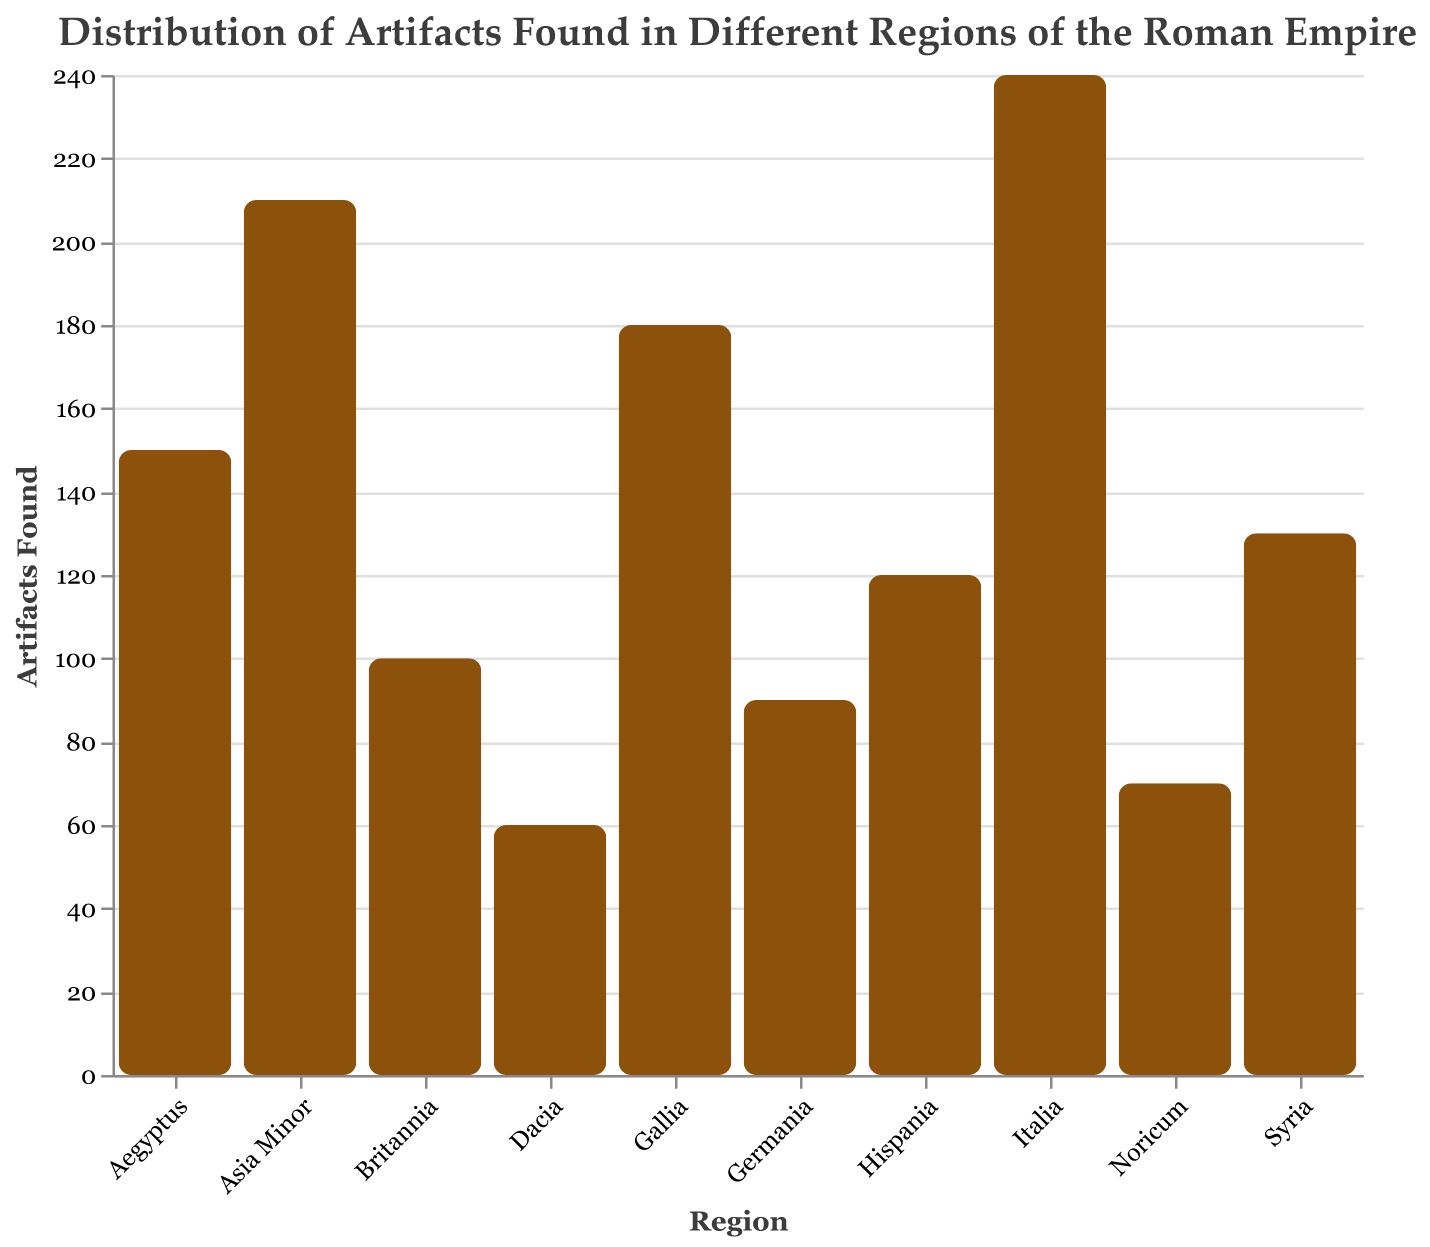What's the title of the figure? The title is usually displayed at the top of the figure. In this case, the title is specified in the title section of the figure code.
Answer: Distribution of Artifacts Found in Different Regions of the Roman Empire How many regions are represented in the figure? Count the number of distinct regions listed on the x-axis. Each bar represents one region.
Answer: 10 Which region found the most artifacts? Look for the bar with the greatest height on the y-axis labeled "Artifacts Found." The highest bar corresponds to the region with the most artifacts.
Answer: Italia Which region found the least artifacts? Identify the bar with the smallest height on the y-axis labeled "Artifacts Found." The lowest bar indicates the region with the fewest artifacts.
Answer: Dacia How many artifacts were found in Gallia and Hispania combined? Locate the values for Gallia (180) and Hispania (120) from the bars. Add these two values together. 180 + 120 = 300
Answer: 300 What is the difference between artifacts found in Italia and Aegyptus? Locate the bars representing Italia (240) and Aegyptus (150). Subtract the number of artifacts found in Aegyptus from the number of artifacts found in Italia. 240 - 150 = 90
Answer: 90 Which region found more artifacts, Syria or Germania? Compare the heights of the bars for Syria (130) and Germania (90). The bar for Syria is taller, indicating it found more artifacts.
Answer: Syria What is the average number of artifacts found across all regions? Sum all the numbers of artifacts found (240 + 180 + 120 + 100 + 150 + 210 + 90 + 60 + 130 + 70) and then divide by the number of regions (10). (240+180+120+100+150+210+90+60+130+70) / 10 = 1350 / 10 = 135
Answer: 135 Are there more or fewer artifacts found in Britannia compared to Noricum? Compare the height of the bars for Britannia (100) and Noricum (70). The bar for Britannia is taller, indicating more artifacts were found there.
Answer: More What's the total number of artifacts found in all regions represented in the figure? Sum all the values for artifacts found across all regions. This is the total count of artifacts. 240 + 180 + 120 + 100 + 150 + 210 + 90 + 60 + 130 + 70 = 1350
Answer: 1350 